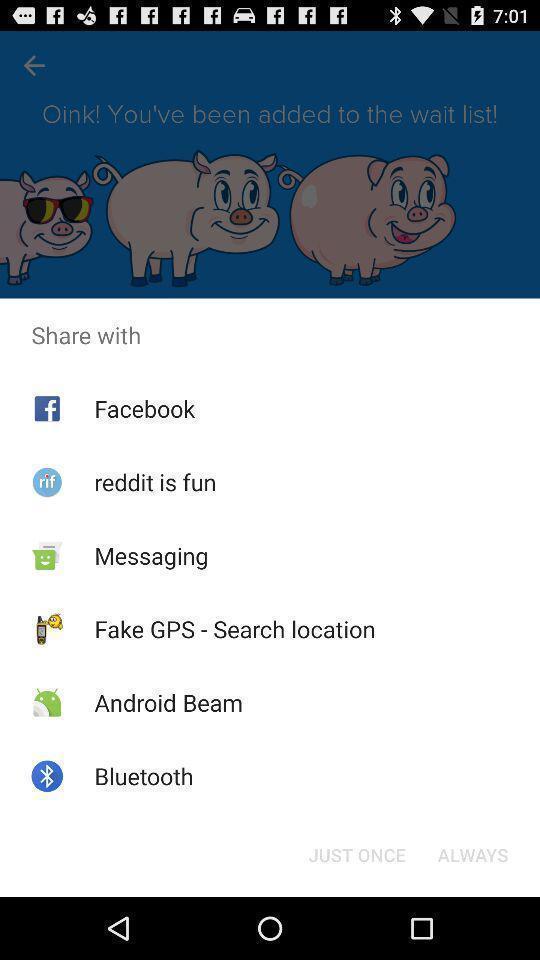Please provide a description for this image. Pop-up widget is showing multiple sharing apps. 